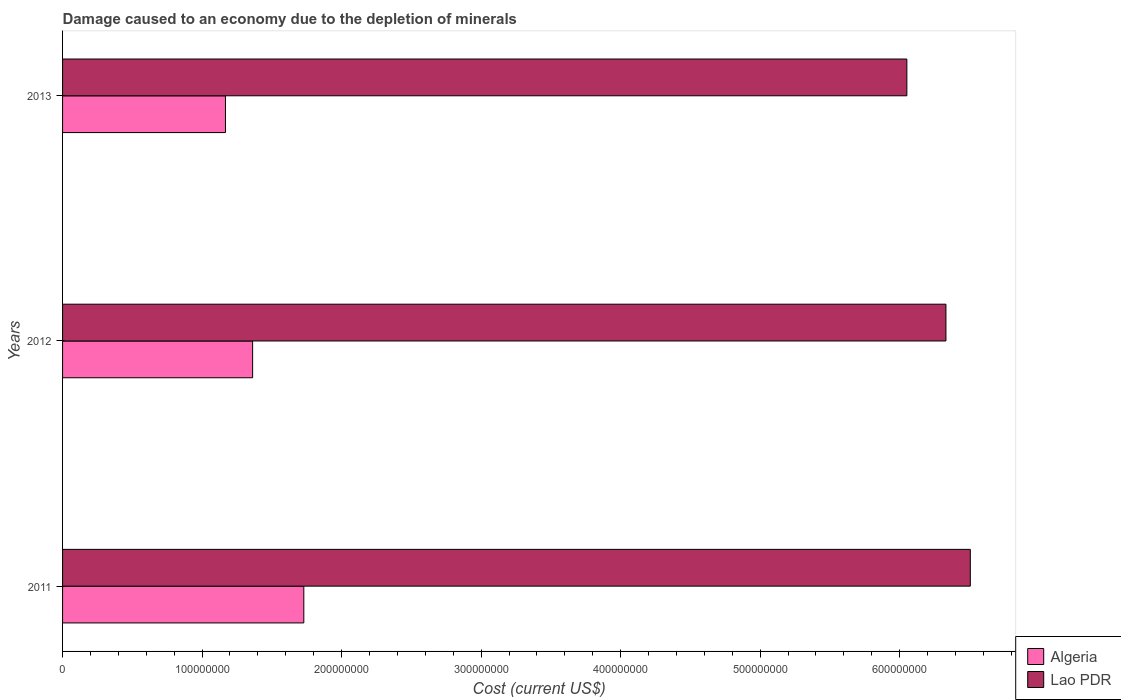How many different coloured bars are there?
Offer a very short reply. 2. How many groups of bars are there?
Offer a very short reply. 3. Are the number of bars per tick equal to the number of legend labels?
Your response must be concise. Yes. Are the number of bars on each tick of the Y-axis equal?
Your answer should be very brief. Yes. How many bars are there on the 3rd tick from the top?
Give a very brief answer. 2. In how many cases, is the number of bars for a given year not equal to the number of legend labels?
Your answer should be compact. 0. What is the cost of damage caused due to the depletion of minerals in Algeria in 2012?
Keep it short and to the point. 1.36e+08. Across all years, what is the maximum cost of damage caused due to the depletion of minerals in Lao PDR?
Make the answer very short. 6.51e+08. Across all years, what is the minimum cost of damage caused due to the depletion of minerals in Algeria?
Offer a very short reply. 1.17e+08. In which year was the cost of damage caused due to the depletion of minerals in Algeria maximum?
Your answer should be very brief. 2011. In which year was the cost of damage caused due to the depletion of minerals in Lao PDR minimum?
Provide a short and direct response. 2013. What is the total cost of damage caused due to the depletion of minerals in Algeria in the graph?
Provide a short and direct response. 4.26e+08. What is the difference between the cost of damage caused due to the depletion of minerals in Lao PDR in 2011 and that in 2012?
Offer a very short reply. 1.75e+07. What is the difference between the cost of damage caused due to the depletion of minerals in Lao PDR in 2011 and the cost of damage caused due to the depletion of minerals in Algeria in 2012?
Give a very brief answer. 5.14e+08. What is the average cost of damage caused due to the depletion of minerals in Lao PDR per year?
Your answer should be compact. 6.30e+08. In the year 2011, what is the difference between the cost of damage caused due to the depletion of minerals in Lao PDR and cost of damage caused due to the depletion of minerals in Algeria?
Keep it short and to the point. 4.78e+08. What is the ratio of the cost of damage caused due to the depletion of minerals in Algeria in 2011 to that in 2012?
Keep it short and to the point. 1.27. Is the difference between the cost of damage caused due to the depletion of minerals in Lao PDR in 2012 and 2013 greater than the difference between the cost of damage caused due to the depletion of minerals in Algeria in 2012 and 2013?
Give a very brief answer. Yes. What is the difference between the highest and the second highest cost of damage caused due to the depletion of minerals in Algeria?
Provide a succinct answer. 3.67e+07. What is the difference between the highest and the lowest cost of damage caused due to the depletion of minerals in Algeria?
Offer a terse response. 5.62e+07. In how many years, is the cost of damage caused due to the depletion of minerals in Lao PDR greater than the average cost of damage caused due to the depletion of minerals in Lao PDR taken over all years?
Provide a succinct answer. 2. What does the 2nd bar from the top in 2013 represents?
Make the answer very short. Algeria. What does the 1st bar from the bottom in 2011 represents?
Keep it short and to the point. Algeria. What is the difference between two consecutive major ticks on the X-axis?
Make the answer very short. 1.00e+08. Does the graph contain grids?
Offer a terse response. No. Where does the legend appear in the graph?
Keep it short and to the point. Bottom right. How are the legend labels stacked?
Your answer should be very brief. Vertical. What is the title of the graph?
Keep it short and to the point. Damage caused to an economy due to the depletion of minerals. Does "Paraguay" appear as one of the legend labels in the graph?
Provide a short and direct response. No. What is the label or title of the X-axis?
Your response must be concise. Cost (current US$). What is the Cost (current US$) of Algeria in 2011?
Your response must be concise. 1.73e+08. What is the Cost (current US$) in Lao PDR in 2011?
Ensure brevity in your answer.  6.51e+08. What is the Cost (current US$) of Algeria in 2012?
Offer a very short reply. 1.36e+08. What is the Cost (current US$) of Lao PDR in 2012?
Offer a terse response. 6.33e+08. What is the Cost (current US$) in Algeria in 2013?
Your response must be concise. 1.17e+08. What is the Cost (current US$) of Lao PDR in 2013?
Provide a short and direct response. 6.05e+08. Across all years, what is the maximum Cost (current US$) of Algeria?
Make the answer very short. 1.73e+08. Across all years, what is the maximum Cost (current US$) of Lao PDR?
Provide a succinct answer. 6.51e+08. Across all years, what is the minimum Cost (current US$) in Algeria?
Ensure brevity in your answer.  1.17e+08. Across all years, what is the minimum Cost (current US$) of Lao PDR?
Make the answer very short. 6.05e+08. What is the total Cost (current US$) of Algeria in the graph?
Offer a very short reply. 4.26e+08. What is the total Cost (current US$) of Lao PDR in the graph?
Your answer should be very brief. 1.89e+09. What is the difference between the Cost (current US$) in Algeria in 2011 and that in 2012?
Provide a short and direct response. 3.67e+07. What is the difference between the Cost (current US$) in Lao PDR in 2011 and that in 2012?
Give a very brief answer. 1.75e+07. What is the difference between the Cost (current US$) of Algeria in 2011 and that in 2013?
Provide a succinct answer. 5.62e+07. What is the difference between the Cost (current US$) of Lao PDR in 2011 and that in 2013?
Offer a very short reply. 4.55e+07. What is the difference between the Cost (current US$) in Algeria in 2012 and that in 2013?
Offer a very short reply. 1.95e+07. What is the difference between the Cost (current US$) of Lao PDR in 2012 and that in 2013?
Make the answer very short. 2.80e+07. What is the difference between the Cost (current US$) of Algeria in 2011 and the Cost (current US$) of Lao PDR in 2012?
Keep it short and to the point. -4.60e+08. What is the difference between the Cost (current US$) in Algeria in 2011 and the Cost (current US$) in Lao PDR in 2013?
Your answer should be compact. -4.32e+08. What is the difference between the Cost (current US$) in Algeria in 2012 and the Cost (current US$) in Lao PDR in 2013?
Offer a terse response. -4.69e+08. What is the average Cost (current US$) in Algeria per year?
Provide a short and direct response. 1.42e+08. What is the average Cost (current US$) of Lao PDR per year?
Your response must be concise. 6.30e+08. In the year 2011, what is the difference between the Cost (current US$) in Algeria and Cost (current US$) in Lao PDR?
Offer a terse response. -4.78e+08. In the year 2012, what is the difference between the Cost (current US$) in Algeria and Cost (current US$) in Lao PDR?
Provide a short and direct response. -4.97e+08. In the year 2013, what is the difference between the Cost (current US$) of Algeria and Cost (current US$) of Lao PDR?
Provide a short and direct response. -4.88e+08. What is the ratio of the Cost (current US$) of Algeria in 2011 to that in 2012?
Ensure brevity in your answer.  1.27. What is the ratio of the Cost (current US$) of Lao PDR in 2011 to that in 2012?
Offer a terse response. 1.03. What is the ratio of the Cost (current US$) of Algeria in 2011 to that in 2013?
Provide a short and direct response. 1.48. What is the ratio of the Cost (current US$) of Lao PDR in 2011 to that in 2013?
Offer a terse response. 1.08. What is the ratio of the Cost (current US$) in Lao PDR in 2012 to that in 2013?
Give a very brief answer. 1.05. What is the difference between the highest and the second highest Cost (current US$) in Algeria?
Offer a very short reply. 3.67e+07. What is the difference between the highest and the second highest Cost (current US$) in Lao PDR?
Your response must be concise. 1.75e+07. What is the difference between the highest and the lowest Cost (current US$) of Algeria?
Your response must be concise. 5.62e+07. What is the difference between the highest and the lowest Cost (current US$) of Lao PDR?
Give a very brief answer. 4.55e+07. 